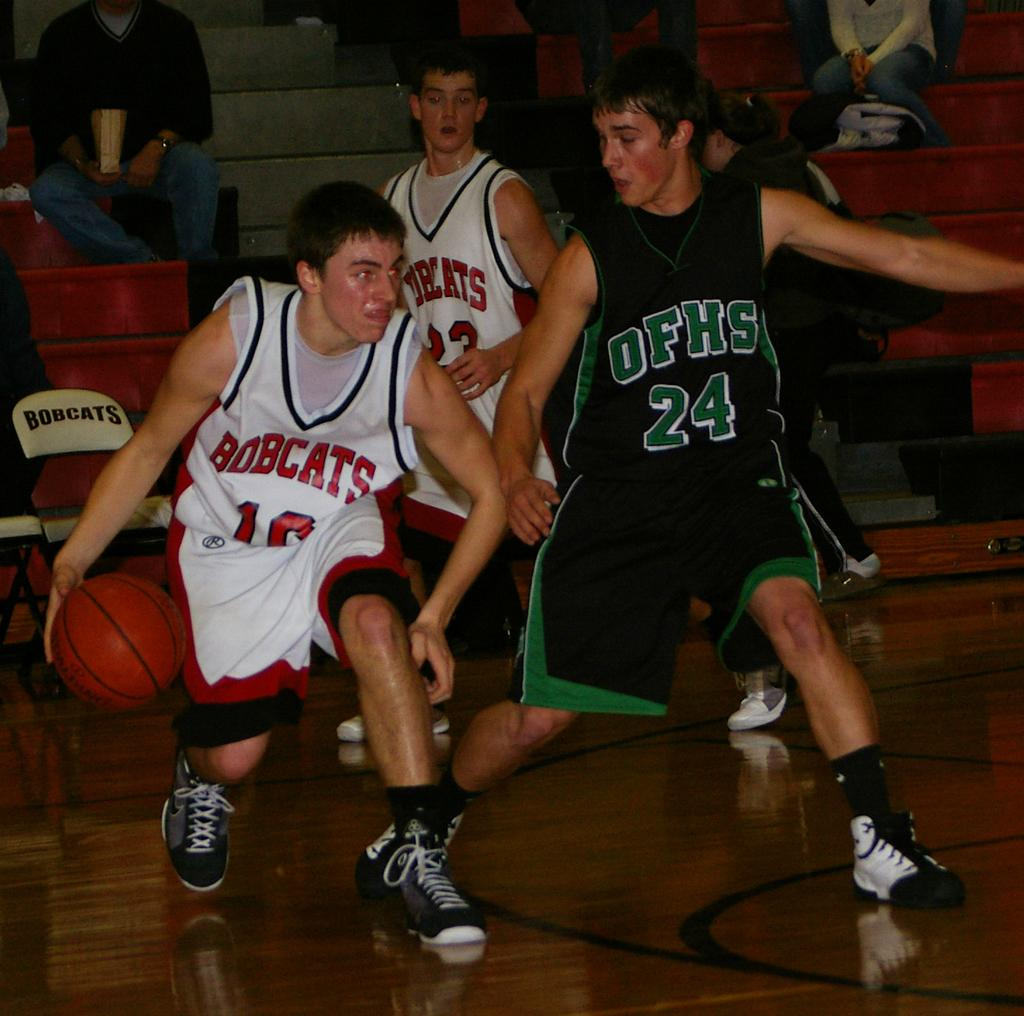<image>
Render a clear and concise summary of the photo. Basketball student from team Bobcats is trying to score against the opposing player. 